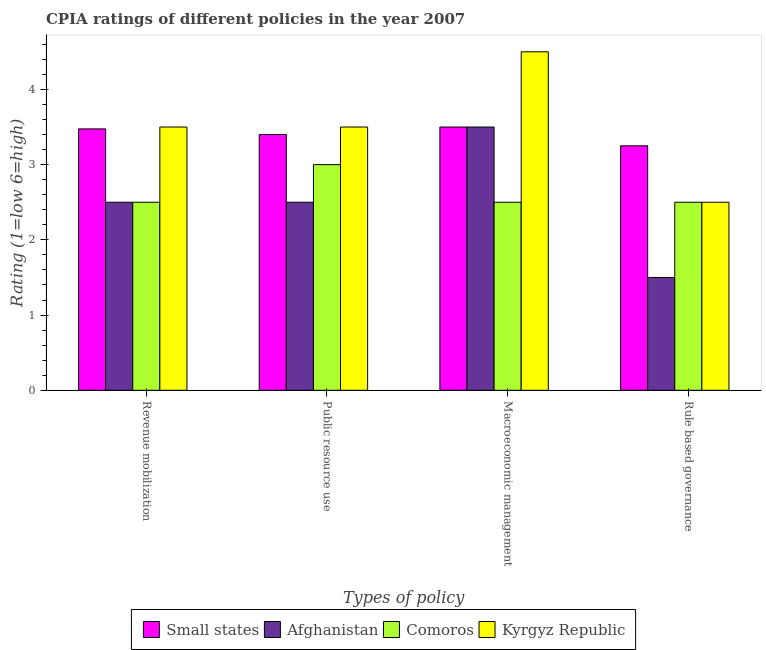How many different coloured bars are there?
Provide a short and direct response. 4. Are the number of bars on each tick of the X-axis equal?
Your answer should be very brief. Yes. What is the label of the 1st group of bars from the left?
Your answer should be compact. Revenue mobilization. Across all countries, what is the maximum cpia rating of revenue mobilization?
Ensure brevity in your answer.  3.5. Across all countries, what is the minimum cpia rating of public resource use?
Give a very brief answer. 2.5. In which country was the cpia rating of public resource use maximum?
Offer a terse response. Kyrgyz Republic. In which country was the cpia rating of revenue mobilization minimum?
Offer a very short reply. Afghanistan. What is the total cpia rating of macroeconomic management in the graph?
Make the answer very short. 14. What is the difference between the cpia rating of public resource use in Comoros and that in Small states?
Offer a terse response. -0.4. What is the average cpia rating of macroeconomic management per country?
Provide a succinct answer. 3.5. In how many countries, is the cpia rating of macroeconomic management greater than 0.8 ?
Give a very brief answer. 4. What is the difference between the highest and the second highest cpia rating of revenue mobilization?
Give a very brief answer. 0.02. Is it the case that in every country, the sum of the cpia rating of macroeconomic management and cpia rating of public resource use is greater than the sum of cpia rating of rule based governance and cpia rating of revenue mobilization?
Keep it short and to the point. No. What does the 3rd bar from the left in Rule based governance represents?
Ensure brevity in your answer.  Comoros. What does the 3rd bar from the right in Macroeconomic management represents?
Make the answer very short. Afghanistan. Is it the case that in every country, the sum of the cpia rating of revenue mobilization and cpia rating of public resource use is greater than the cpia rating of macroeconomic management?
Give a very brief answer. Yes. How many bars are there?
Provide a succinct answer. 16. How many countries are there in the graph?
Your answer should be compact. 4. Does the graph contain grids?
Provide a short and direct response. No. How many legend labels are there?
Offer a terse response. 4. How are the legend labels stacked?
Give a very brief answer. Horizontal. What is the title of the graph?
Keep it short and to the point. CPIA ratings of different policies in the year 2007. What is the label or title of the X-axis?
Give a very brief answer. Types of policy. What is the Rating (1=low 6=high) of Small states in Revenue mobilization?
Give a very brief answer. 3.48. What is the Rating (1=low 6=high) of Afghanistan in Revenue mobilization?
Offer a terse response. 2.5. What is the Rating (1=low 6=high) of Comoros in Revenue mobilization?
Your answer should be very brief. 2.5. What is the Rating (1=low 6=high) of Afghanistan in Public resource use?
Offer a very short reply. 2.5. What is the Rating (1=low 6=high) in Comoros in Public resource use?
Offer a terse response. 3. What is the Rating (1=low 6=high) of Comoros in Macroeconomic management?
Your response must be concise. 2.5. What is the Rating (1=low 6=high) in Kyrgyz Republic in Macroeconomic management?
Your response must be concise. 4.5. What is the Rating (1=low 6=high) of Comoros in Rule based governance?
Provide a short and direct response. 2.5. Across all Types of policy, what is the maximum Rating (1=low 6=high) in Small states?
Your response must be concise. 3.5. Across all Types of policy, what is the maximum Rating (1=low 6=high) of Afghanistan?
Your answer should be very brief. 3.5. Across all Types of policy, what is the maximum Rating (1=low 6=high) of Kyrgyz Republic?
Make the answer very short. 4.5. Across all Types of policy, what is the minimum Rating (1=low 6=high) in Small states?
Ensure brevity in your answer.  3.25. Across all Types of policy, what is the minimum Rating (1=low 6=high) in Comoros?
Offer a very short reply. 2.5. Across all Types of policy, what is the minimum Rating (1=low 6=high) of Kyrgyz Republic?
Your answer should be compact. 2.5. What is the total Rating (1=low 6=high) in Small states in the graph?
Your answer should be very brief. 13.62. What is the total Rating (1=low 6=high) of Comoros in the graph?
Your response must be concise. 10.5. What is the total Rating (1=low 6=high) of Kyrgyz Republic in the graph?
Keep it short and to the point. 14. What is the difference between the Rating (1=low 6=high) of Small states in Revenue mobilization and that in Public resource use?
Offer a very short reply. 0.07. What is the difference between the Rating (1=low 6=high) in Afghanistan in Revenue mobilization and that in Public resource use?
Keep it short and to the point. 0. What is the difference between the Rating (1=low 6=high) of Small states in Revenue mobilization and that in Macroeconomic management?
Your answer should be compact. -0.03. What is the difference between the Rating (1=low 6=high) of Kyrgyz Republic in Revenue mobilization and that in Macroeconomic management?
Offer a terse response. -1. What is the difference between the Rating (1=low 6=high) in Small states in Revenue mobilization and that in Rule based governance?
Your answer should be compact. 0.23. What is the difference between the Rating (1=low 6=high) in Kyrgyz Republic in Revenue mobilization and that in Rule based governance?
Make the answer very short. 1. What is the difference between the Rating (1=low 6=high) of Small states in Public resource use and that in Macroeconomic management?
Your response must be concise. -0.1. What is the difference between the Rating (1=low 6=high) of Afghanistan in Public resource use and that in Macroeconomic management?
Give a very brief answer. -1. What is the difference between the Rating (1=low 6=high) in Comoros in Public resource use and that in Macroeconomic management?
Make the answer very short. 0.5. What is the difference between the Rating (1=low 6=high) of Small states in Macroeconomic management and that in Rule based governance?
Your response must be concise. 0.25. What is the difference between the Rating (1=low 6=high) in Small states in Revenue mobilization and the Rating (1=low 6=high) in Afghanistan in Public resource use?
Give a very brief answer. 0.97. What is the difference between the Rating (1=low 6=high) in Small states in Revenue mobilization and the Rating (1=low 6=high) in Comoros in Public resource use?
Ensure brevity in your answer.  0.47. What is the difference between the Rating (1=low 6=high) of Small states in Revenue mobilization and the Rating (1=low 6=high) of Kyrgyz Republic in Public resource use?
Your response must be concise. -0.03. What is the difference between the Rating (1=low 6=high) in Comoros in Revenue mobilization and the Rating (1=low 6=high) in Kyrgyz Republic in Public resource use?
Your response must be concise. -1. What is the difference between the Rating (1=low 6=high) of Small states in Revenue mobilization and the Rating (1=low 6=high) of Afghanistan in Macroeconomic management?
Ensure brevity in your answer.  -0.03. What is the difference between the Rating (1=low 6=high) of Small states in Revenue mobilization and the Rating (1=low 6=high) of Comoros in Macroeconomic management?
Give a very brief answer. 0.97. What is the difference between the Rating (1=low 6=high) in Small states in Revenue mobilization and the Rating (1=low 6=high) in Kyrgyz Republic in Macroeconomic management?
Provide a succinct answer. -1.02. What is the difference between the Rating (1=low 6=high) of Small states in Revenue mobilization and the Rating (1=low 6=high) of Afghanistan in Rule based governance?
Provide a short and direct response. 1.98. What is the difference between the Rating (1=low 6=high) of Comoros in Revenue mobilization and the Rating (1=low 6=high) of Kyrgyz Republic in Rule based governance?
Provide a short and direct response. 0. What is the difference between the Rating (1=low 6=high) in Small states in Public resource use and the Rating (1=low 6=high) in Comoros in Macroeconomic management?
Your answer should be very brief. 0.9. What is the difference between the Rating (1=low 6=high) in Small states in Public resource use and the Rating (1=low 6=high) in Kyrgyz Republic in Macroeconomic management?
Provide a succinct answer. -1.1. What is the difference between the Rating (1=low 6=high) in Afghanistan in Public resource use and the Rating (1=low 6=high) in Comoros in Macroeconomic management?
Offer a very short reply. 0. What is the difference between the Rating (1=low 6=high) in Small states in Public resource use and the Rating (1=low 6=high) in Kyrgyz Republic in Rule based governance?
Ensure brevity in your answer.  0.9. What is the difference between the Rating (1=low 6=high) of Afghanistan in Public resource use and the Rating (1=low 6=high) of Comoros in Rule based governance?
Your response must be concise. 0. What is the difference between the Rating (1=low 6=high) in Comoros in Public resource use and the Rating (1=low 6=high) in Kyrgyz Republic in Rule based governance?
Ensure brevity in your answer.  0.5. What is the difference between the Rating (1=low 6=high) of Small states in Macroeconomic management and the Rating (1=low 6=high) of Afghanistan in Rule based governance?
Give a very brief answer. 2. What is the difference between the Rating (1=low 6=high) in Small states in Macroeconomic management and the Rating (1=low 6=high) in Comoros in Rule based governance?
Your answer should be very brief. 1. What is the difference between the Rating (1=low 6=high) of Small states in Macroeconomic management and the Rating (1=low 6=high) of Kyrgyz Republic in Rule based governance?
Provide a succinct answer. 1. What is the average Rating (1=low 6=high) of Small states per Types of policy?
Your response must be concise. 3.41. What is the average Rating (1=low 6=high) of Afghanistan per Types of policy?
Provide a succinct answer. 2.5. What is the average Rating (1=low 6=high) of Comoros per Types of policy?
Keep it short and to the point. 2.62. What is the average Rating (1=low 6=high) of Kyrgyz Republic per Types of policy?
Offer a terse response. 3.5. What is the difference between the Rating (1=low 6=high) in Small states and Rating (1=low 6=high) in Afghanistan in Revenue mobilization?
Your answer should be very brief. 0.97. What is the difference between the Rating (1=low 6=high) in Small states and Rating (1=low 6=high) in Comoros in Revenue mobilization?
Your response must be concise. 0.97. What is the difference between the Rating (1=low 6=high) of Small states and Rating (1=low 6=high) of Kyrgyz Republic in Revenue mobilization?
Offer a terse response. -0.03. What is the difference between the Rating (1=low 6=high) of Afghanistan and Rating (1=low 6=high) of Kyrgyz Republic in Revenue mobilization?
Ensure brevity in your answer.  -1. What is the difference between the Rating (1=low 6=high) in Small states and Rating (1=low 6=high) in Afghanistan in Public resource use?
Make the answer very short. 0.9. What is the difference between the Rating (1=low 6=high) in Small states and Rating (1=low 6=high) in Comoros in Public resource use?
Your answer should be compact. 0.4. What is the difference between the Rating (1=low 6=high) in Afghanistan and Rating (1=low 6=high) in Comoros in Public resource use?
Give a very brief answer. -0.5. What is the difference between the Rating (1=low 6=high) in Afghanistan and Rating (1=low 6=high) in Kyrgyz Republic in Public resource use?
Your response must be concise. -1. What is the difference between the Rating (1=low 6=high) of Small states and Rating (1=low 6=high) of Comoros in Macroeconomic management?
Keep it short and to the point. 1. What is the difference between the Rating (1=low 6=high) in Small states and Rating (1=low 6=high) in Kyrgyz Republic in Macroeconomic management?
Provide a short and direct response. -1. What is the difference between the Rating (1=low 6=high) in Afghanistan and Rating (1=low 6=high) in Comoros in Macroeconomic management?
Make the answer very short. 1. What is the difference between the Rating (1=low 6=high) of Afghanistan and Rating (1=low 6=high) of Kyrgyz Republic in Macroeconomic management?
Ensure brevity in your answer.  -1. What is the difference between the Rating (1=low 6=high) in Comoros and Rating (1=low 6=high) in Kyrgyz Republic in Macroeconomic management?
Offer a terse response. -2. What is the difference between the Rating (1=low 6=high) in Afghanistan and Rating (1=low 6=high) in Comoros in Rule based governance?
Your response must be concise. -1. What is the ratio of the Rating (1=low 6=high) in Small states in Revenue mobilization to that in Public resource use?
Offer a terse response. 1.02. What is the ratio of the Rating (1=low 6=high) in Afghanistan in Revenue mobilization to that in Public resource use?
Your response must be concise. 1. What is the ratio of the Rating (1=low 6=high) in Comoros in Revenue mobilization to that in Public resource use?
Make the answer very short. 0.83. What is the ratio of the Rating (1=low 6=high) of Small states in Revenue mobilization to that in Macroeconomic management?
Your response must be concise. 0.99. What is the ratio of the Rating (1=low 6=high) in Kyrgyz Republic in Revenue mobilization to that in Macroeconomic management?
Your answer should be very brief. 0.78. What is the ratio of the Rating (1=low 6=high) in Small states in Revenue mobilization to that in Rule based governance?
Provide a short and direct response. 1.07. What is the ratio of the Rating (1=low 6=high) in Afghanistan in Revenue mobilization to that in Rule based governance?
Offer a very short reply. 1.67. What is the ratio of the Rating (1=low 6=high) in Comoros in Revenue mobilization to that in Rule based governance?
Your answer should be compact. 1. What is the ratio of the Rating (1=low 6=high) in Kyrgyz Republic in Revenue mobilization to that in Rule based governance?
Provide a short and direct response. 1.4. What is the ratio of the Rating (1=low 6=high) in Small states in Public resource use to that in Macroeconomic management?
Your answer should be compact. 0.97. What is the ratio of the Rating (1=low 6=high) in Afghanistan in Public resource use to that in Macroeconomic management?
Provide a short and direct response. 0.71. What is the ratio of the Rating (1=low 6=high) of Kyrgyz Republic in Public resource use to that in Macroeconomic management?
Your answer should be compact. 0.78. What is the ratio of the Rating (1=low 6=high) in Small states in Public resource use to that in Rule based governance?
Provide a short and direct response. 1.05. What is the ratio of the Rating (1=low 6=high) in Afghanistan in Public resource use to that in Rule based governance?
Keep it short and to the point. 1.67. What is the ratio of the Rating (1=low 6=high) of Afghanistan in Macroeconomic management to that in Rule based governance?
Offer a very short reply. 2.33. What is the difference between the highest and the second highest Rating (1=low 6=high) of Small states?
Offer a very short reply. 0.03. What is the difference between the highest and the second highest Rating (1=low 6=high) in Kyrgyz Republic?
Give a very brief answer. 1. What is the difference between the highest and the lowest Rating (1=low 6=high) in Afghanistan?
Offer a terse response. 2. 